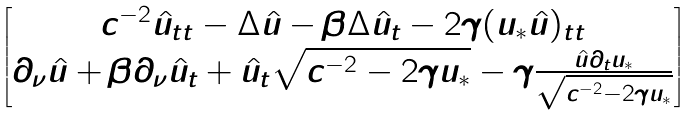<formula> <loc_0><loc_0><loc_500><loc_500>\begin{bmatrix} c ^ { - 2 } \hat { u } _ { t t } - \Delta \hat { u } - \beta \Delta \hat { u } _ { t } - 2 \gamma ( u _ { * } \hat { u } ) _ { t t } \\ \partial _ { \nu } \hat { u } + \beta \partial _ { \nu } \hat { u } _ { t } + \hat { u } _ { t } \sqrt { c ^ { - 2 } - 2 \gamma u _ { * } } - \gamma \frac { \hat { u } \partial _ { t } u _ { * } } { \sqrt { c ^ { - 2 } - 2 \gamma u _ { * } } } \end{bmatrix}</formula> 